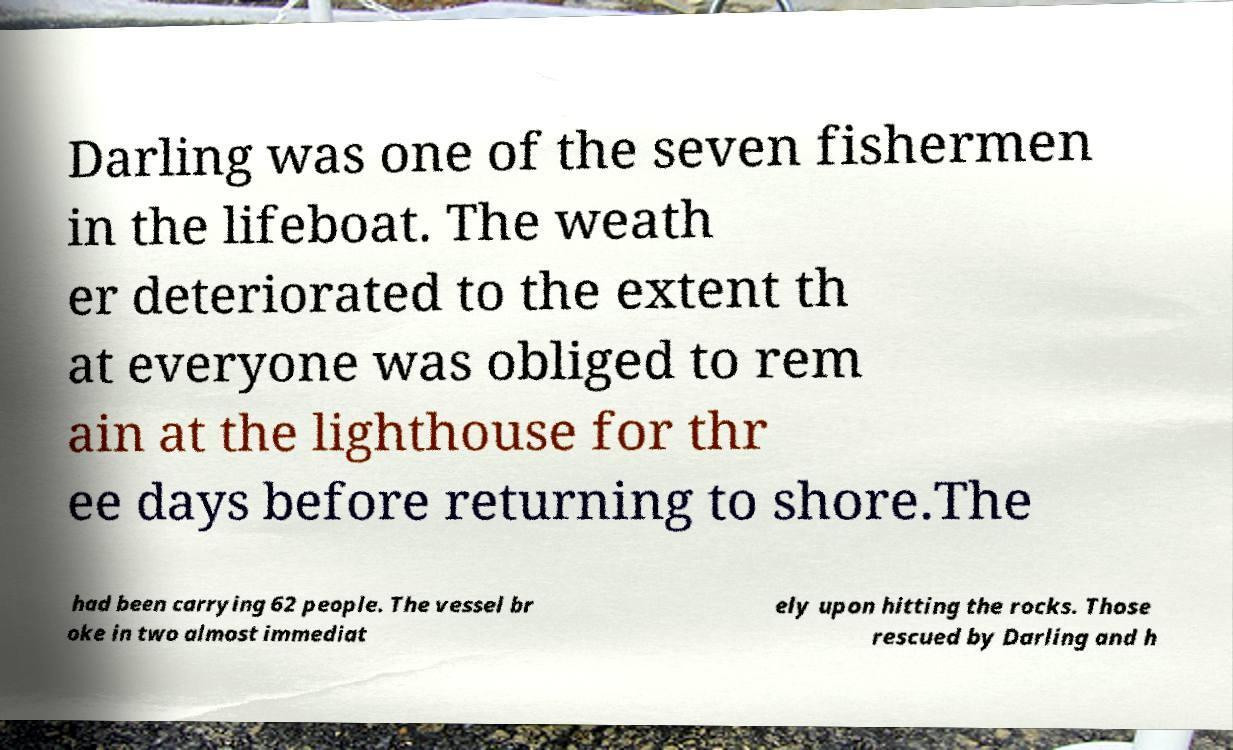There's text embedded in this image that I need extracted. Can you transcribe it verbatim? Darling was one of the seven fishermen in the lifeboat. The weath er deteriorated to the extent th at everyone was obliged to rem ain at the lighthouse for thr ee days before returning to shore.The had been carrying 62 people. The vessel br oke in two almost immediat ely upon hitting the rocks. Those rescued by Darling and h 